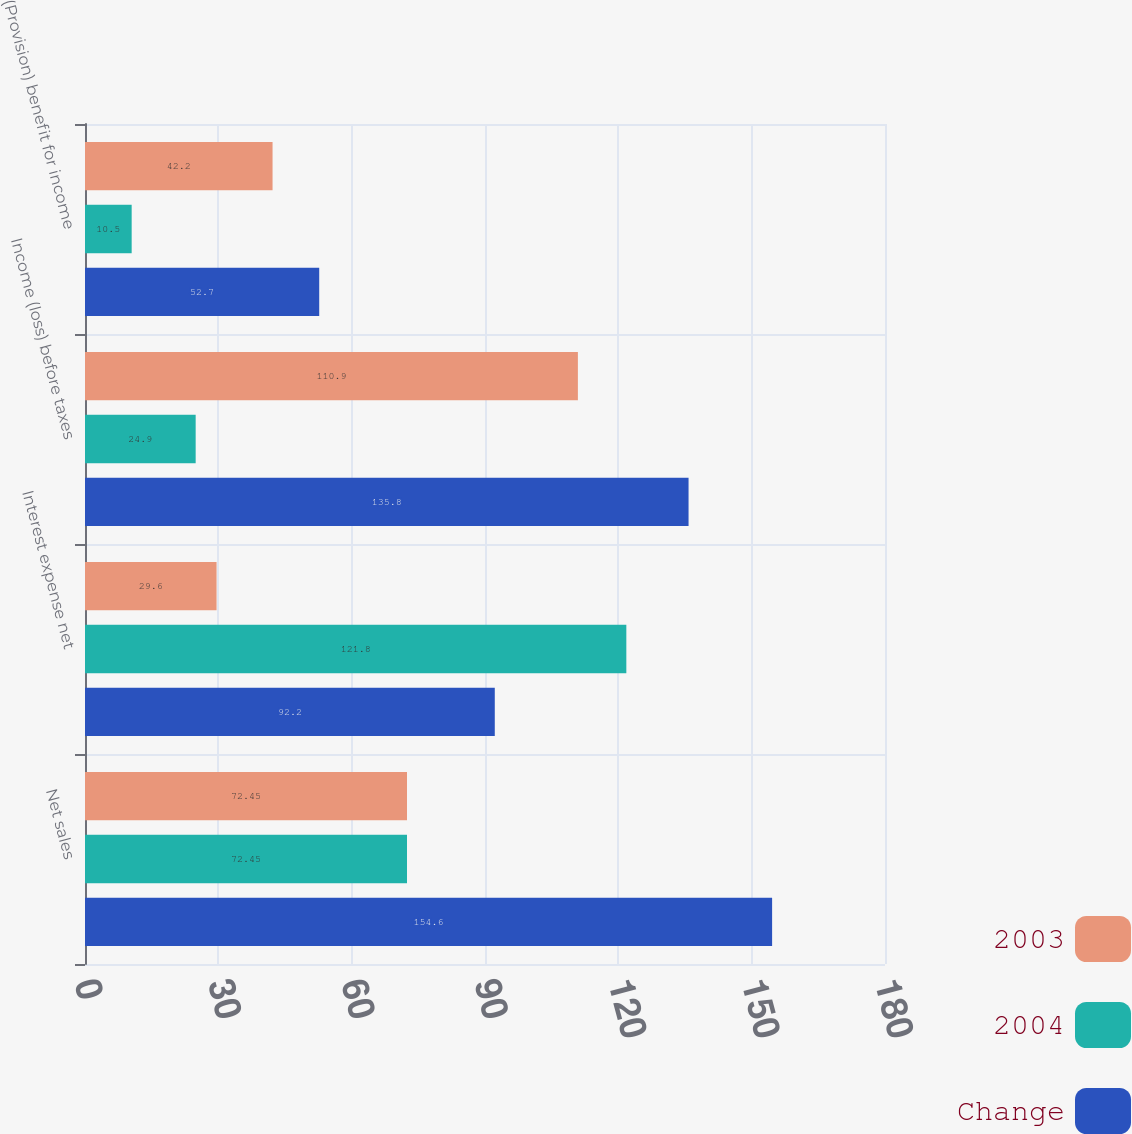Convert chart. <chart><loc_0><loc_0><loc_500><loc_500><stacked_bar_chart><ecel><fcel>Net sales<fcel>Interest expense net<fcel>Income (loss) before taxes<fcel>(Provision) benefit for income<nl><fcel>2003<fcel>72.45<fcel>29.6<fcel>110.9<fcel>42.2<nl><fcel>2004<fcel>72.45<fcel>121.8<fcel>24.9<fcel>10.5<nl><fcel>Change<fcel>154.6<fcel>92.2<fcel>135.8<fcel>52.7<nl></chart> 